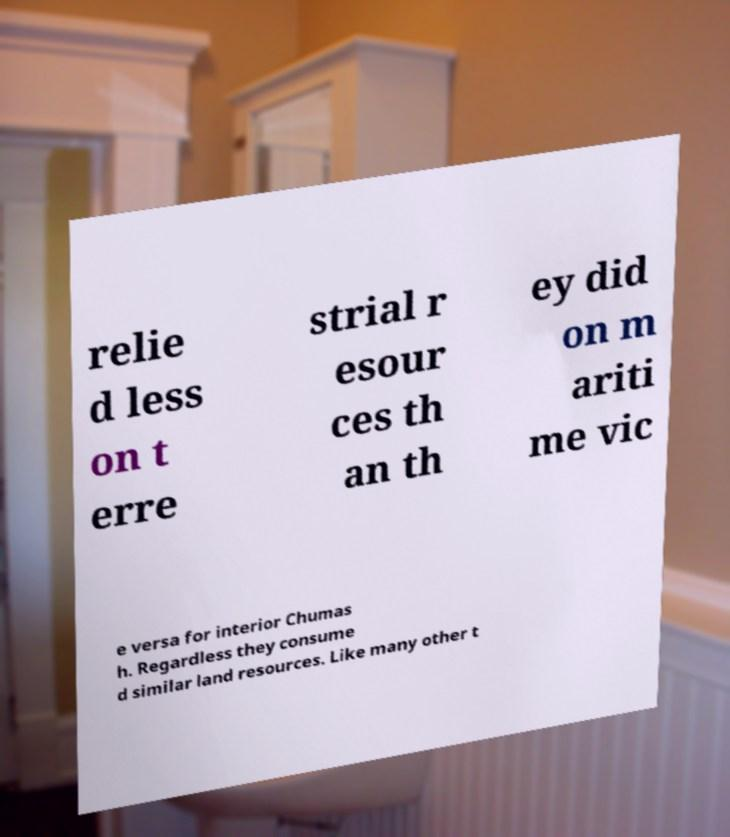Can you read and provide the text displayed in the image?This photo seems to have some interesting text. Can you extract and type it out for me? relie d less on t erre strial r esour ces th an th ey did on m ariti me vic e versa for interior Chumas h. Regardless they consume d similar land resources. Like many other t 